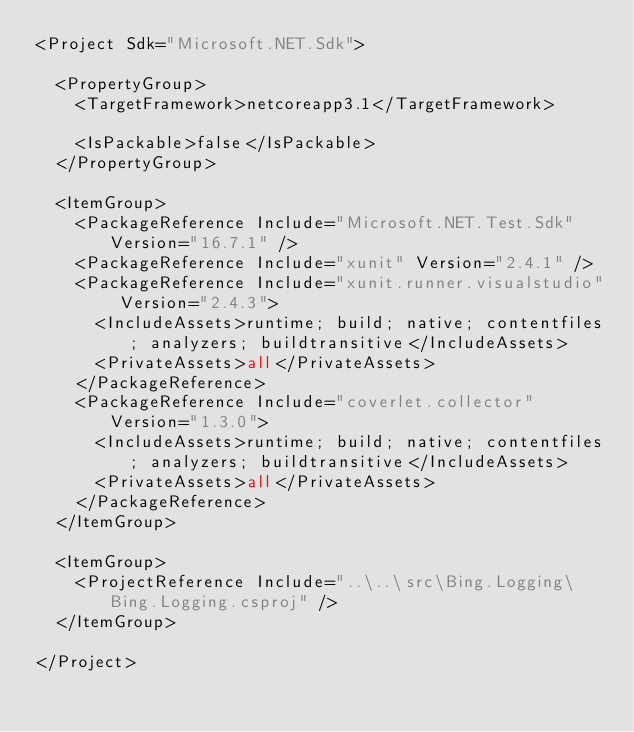<code> <loc_0><loc_0><loc_500><loc_500><_XML_><Project Sdk="Microsoft.NET.Sdk">

  <PropertyGroup>
    <TargetFramework>netcoreapp3.1</TargetFramework>

    <IsPackable>false</IsPackable>
  </PropertyGroup>

  <ItemGroup>
    <PackageReference Include="Microsoft.NET.Test.Sdk" Version="16.7.1" />
    <PackageReference Include="xunit" Version="2.4.1" />
    <PackageReference Include="xunit.runner.visualstudio" Version="2.4.3">
      <IncludeAssets>runtime; build; native; contentfiles; analyzers; buildtransitive</IncludeAssets>
      <PrivateAssets>all</PrivateAssets>
    </PackageReference>
    <PackageReference Include="coverlet.collector" Version="1.3.0">
      <IncludeAssets>runtime; build; native; contentfiles; analyzers; buildtransitive</IncludeAssets>
      <PrivateAssets>all</PrivateAssets>
    </PackageReference>
  </ItemGroup>

  <ItemGroup>
    <ProjectReference Include="..\..\src\Bing.Logging\Bing.Logging.csproj" />
  </ItemGroup>

</Project>
</code> 